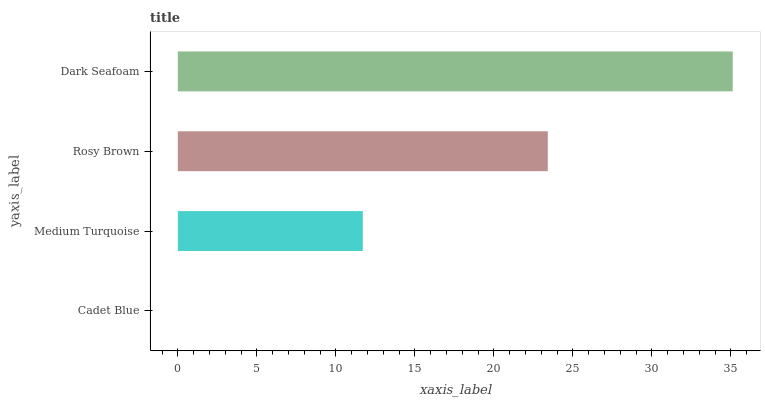Is Cadet Blue the minimum?
Answer yes or no. Yes. Is Dark Seafoam the maximum?
Answer yes or no. Yes. Is Medium Turquoise the minimum?
Answer yes or no. No. Is Medium Turquoise the maximum?
Answer yes or no. No. Is Medium Turquoise greater than Cadet Blue?
Answer yes or no. Yes. Is Cadet Blue less than Medium Turquoise?
Answer yes or no. Yes. Is Cadet Blue greater than Medium Turquoise?
Answer yes or no. No. Is Medium Turquoise less than Cadet Blue?
Answer yes or no. No. Is Rosy Brown the high median?
Answer yes or no. Yes. Is Medium Turquoise the low median?
Answer yes or no. Yes. Is Medium Turquoise the high median?
Answer yes or no. No. Is Rosy Brown the low median?
Answer yes or no. No. 